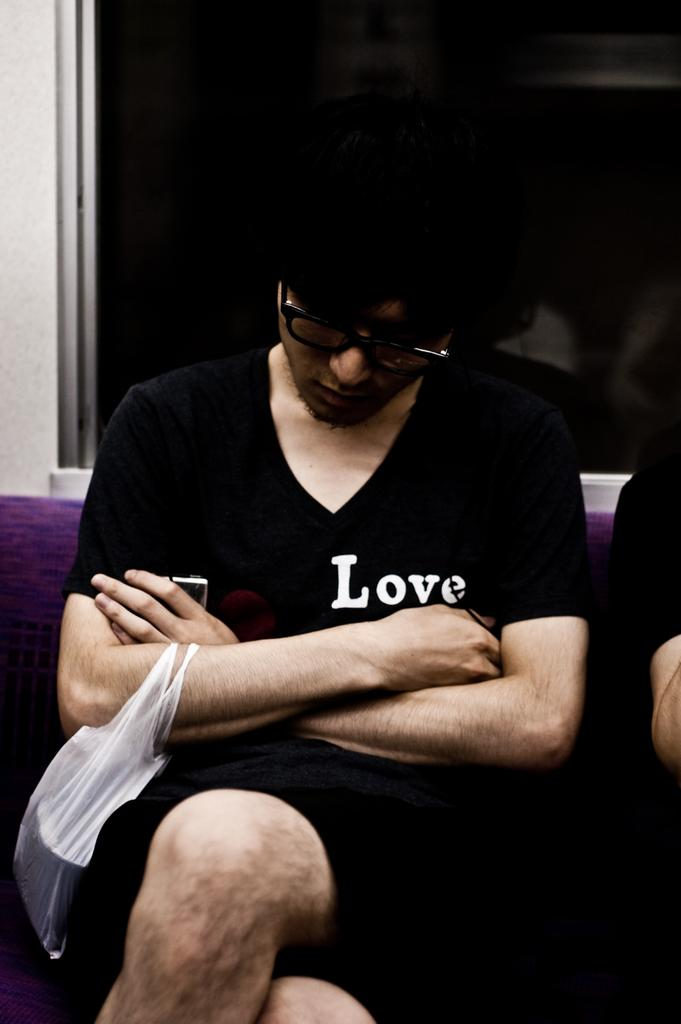What is the man in the image doing? The man is sitting on a sofa in the image. What is the man holding or carrying? The man is carrying a cover. Can you describe the presence of another person in the image? There is a hand of a person beside the man. What can be seen in the background of the image? There is a wall and a glass window in the background of the image. What type of cookware is being adjusted on the stove in the image? There is no cookware or stove present in the image; it features a man sitting on a sofa carrying a cover. 